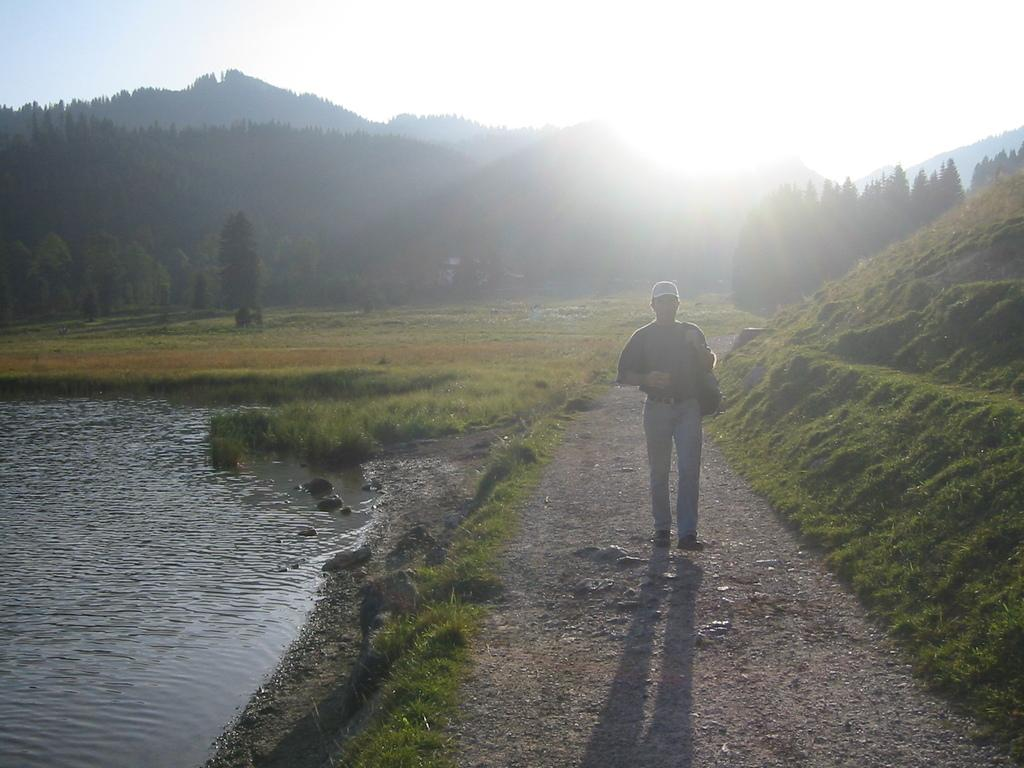What is the main subject of the image? There is a person in the image. What is the person wearing on their head? The person is wearing a cap. What is the person carrying in the image? The person is carrying a bag. What can be seen on the left side of the image? There is water on the left side of the image. What type of vegetation is present on the ground in the image? There is grass on the ground in the image. What is visible in the background of the image? There are trees in the background of the image. What part of the natural environment is visible in the image? The sky is visible in the image. What type of fog can be seen in the image? There is no fog present in the image. How many blades are visible in the image? There are no blades visible in the image. 